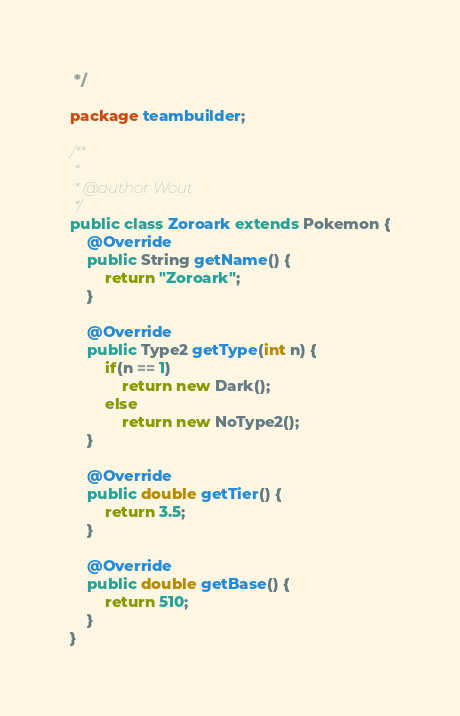Convert code to text. <code><loc_0><loc_0><loc_500><loc_500><_Java_> */

package teambuilder;

/**
 *
 * @author Wout
 */
public class Zoroark extends Pokemon {
    @Override
    public String getName() {
        return "Zoroark";
    }

    @Override
    public Type2 getType(int n) {
        if(n == 1)
            return new Dark();
        else
            return new NoType2();
    }
    
    @Override
    public double getTier() {
        return 3.5;
    }
    
    @Override
    public double getBase() {
        return 510;
    }
}
</code> 